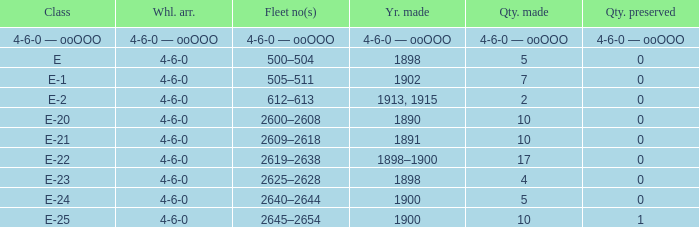What is the quantity made of the e-22 class, which has a quantity preserved of 0? 17.0. 